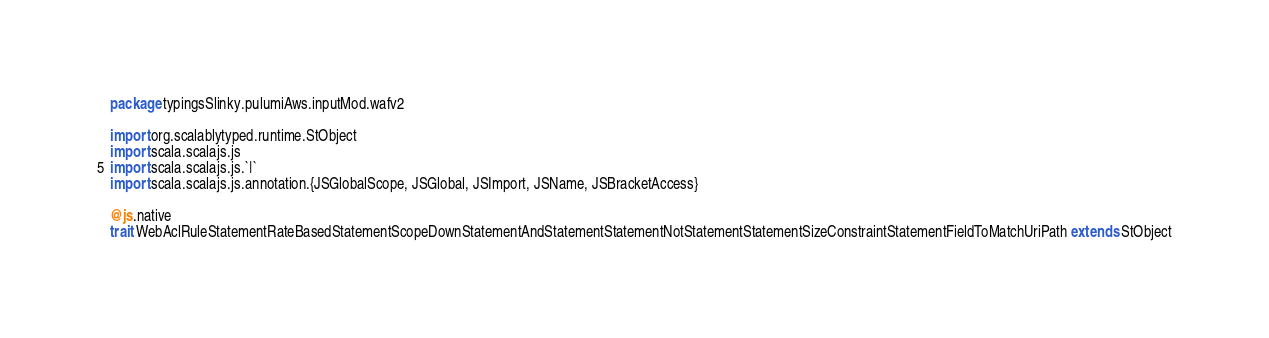Convert code to text. <code><loc_0><loc_0><loc_500><loc_500><_Scala_>package typingsSlinky.pulumiAws.inputMod.wafv2

import org.scalablytyped.runtime.StObject
import scala.scalajs.js
import scala.scalajs.js.`|`
import scala.scalajs.js.annotation.{JSGlobalScope, JSGlobal, JSImport, JSName, JSBracketAccess}

@js.native
trait WebAclRuleStatementRateBasedStatementScopeDownStatementAndStatementStatementNotStatementStatementSizeConstraintStatementFieldToMatchUriPath extends StObject
</code> 